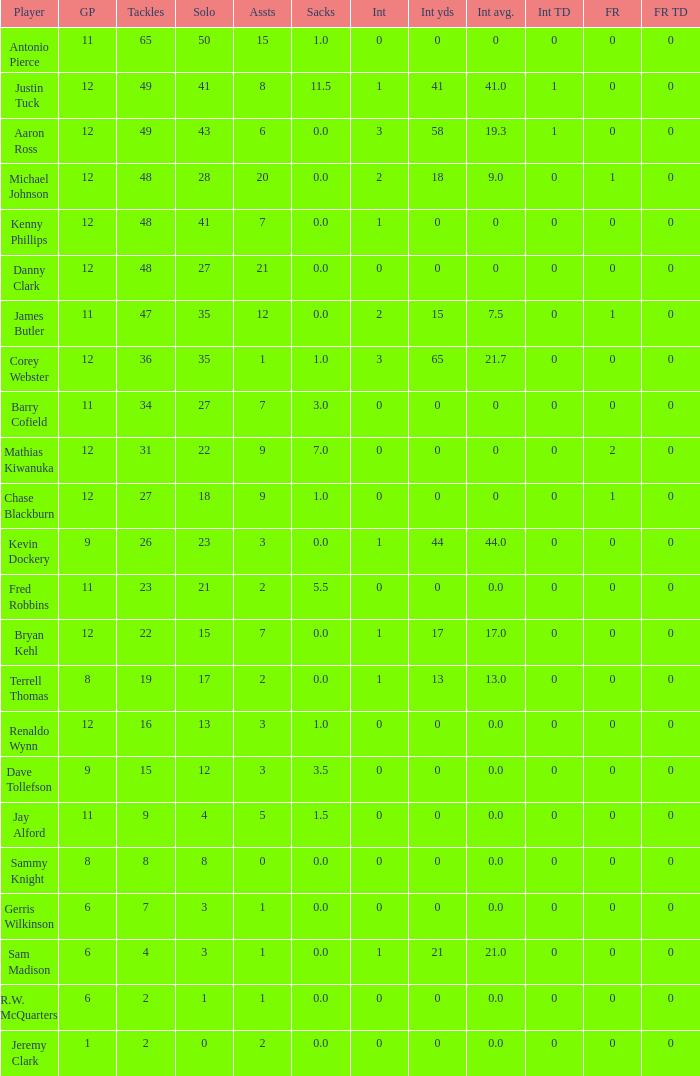Name the least int yards when sacks is 11.5 41.0. 